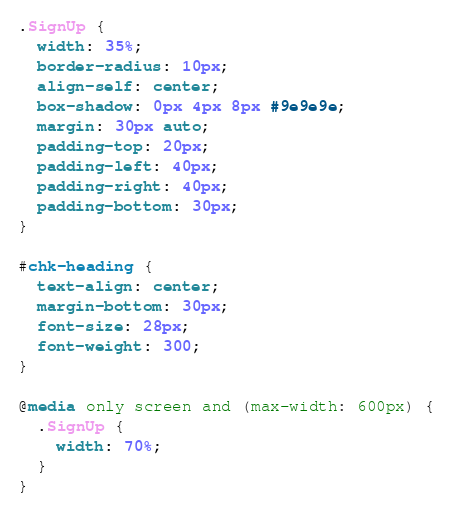<code> <loc_0><loc_0><loc_500><loc_500><_CSS_>.SignUp {
  width: 35%;
  border-radius: 10px;
  align-self: center;
  box-shadow: 0px 4px 8px #9e9e9e;
  margin: 30px auto;
  padding-top: 20px;
  padding-left: 40px;
  padding-right: 40px;
  padding-bottom: 30px;
}

#chk-heading {
  text-align: center;
  margin-bottom: 30px;
  font-size: 28px;
  font-weight: 300;
}

@media only screen and (max-width: 600px) {
  .SignUp {
    width: 70%;
  }
}
</code> 